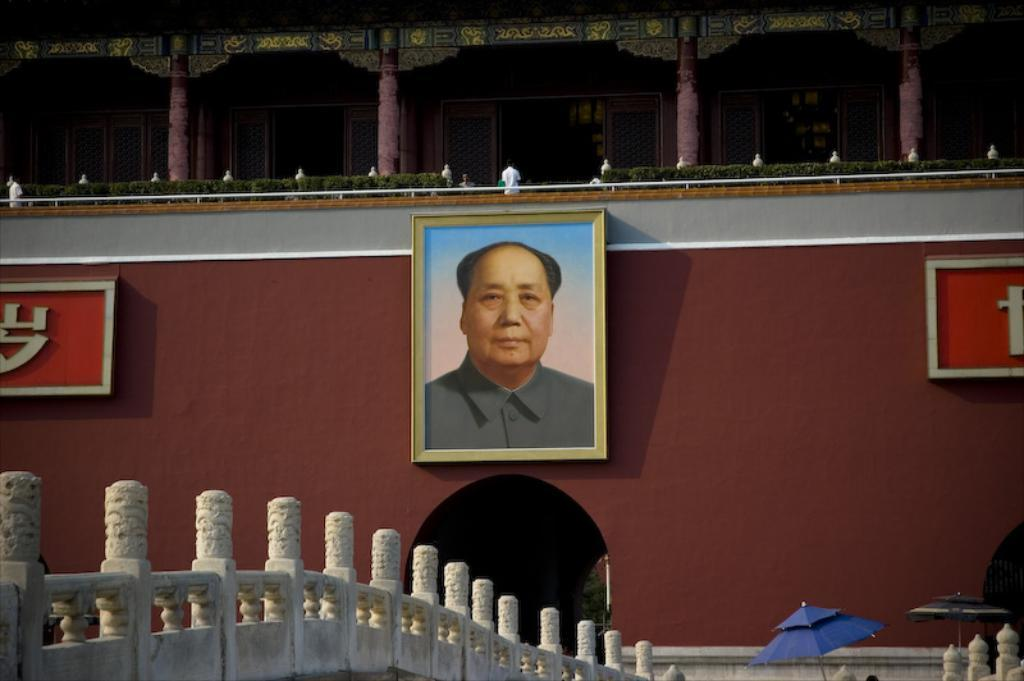What type of structure is visible in the image? There is a building in the image. What architectural feature can be seen on the building? There are pillars in the image. Is there any artwork or decoration on the walls of the building? Yes, there is a photo frame of a person on the wall. What type of transportation feature is present in the image? There is a bridge in the image. What object is used for protection from the rain in the image? There is an umbrella in the image. Are there any signs or messages displayed in the image? Yes, there are boards with text in the image. What type of wire is used to hold up the hope in the image? There is no mention of hope or wire in the image; it features a building, pillars, a photo frame, a bridge, an umbrella, and boards with text. 